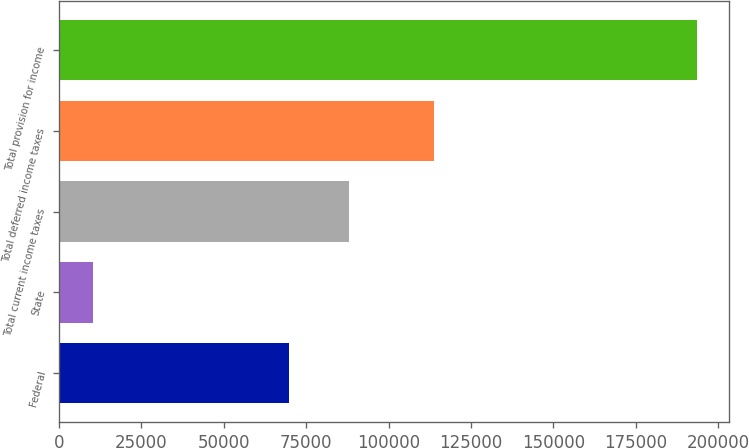<chart> <loc_0><loc_0><loc_500><loc_500><bar_chart><fcel>Federal<fcel>State<fcel>Total current income taxes<fcel>Total deferred income taxes<fcel>Total provision for income<nl><fcel>69698<fcel>10312<fcel>88043.2<fcel>113754<fcel>193532<nl></chart> 